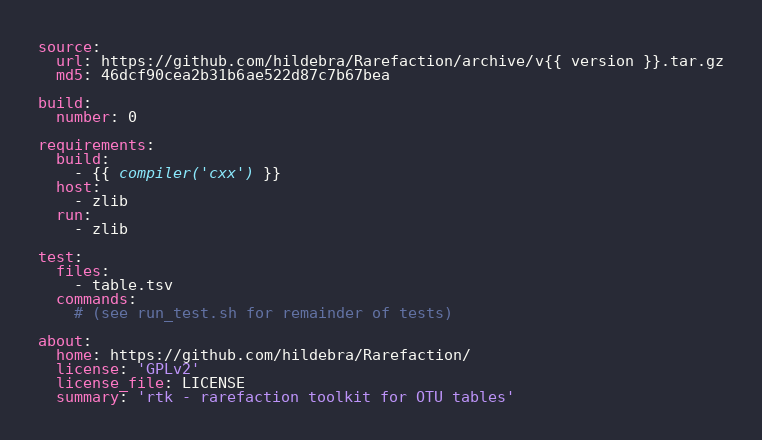Convert code to text. <code><loc_0><loc_0><loc_500><loc_500><_YAML_>source:
  url: https://github.com/hildebra/Rarefaction/archive/v{{ version }}.tar.gz
  md5: 46dcf90cea2b31b6ae522d87c7b67bea

build:
  number: 0

requirements:
  build:
    - {{ compiler('cxx') }}
  host:
    - zlib
  run:
    - zlib

test:
  files:
    - table.tsv
  commands:
    # (see run_test.sh for remainder of tests)

about:
  home: https://github.com/hildebra/Rarefaction/
  license: 'GPLv2'
  license_file: LICENSE
  summary: 'rtk - rarefaction toolkit for OTU tables'
</code> 